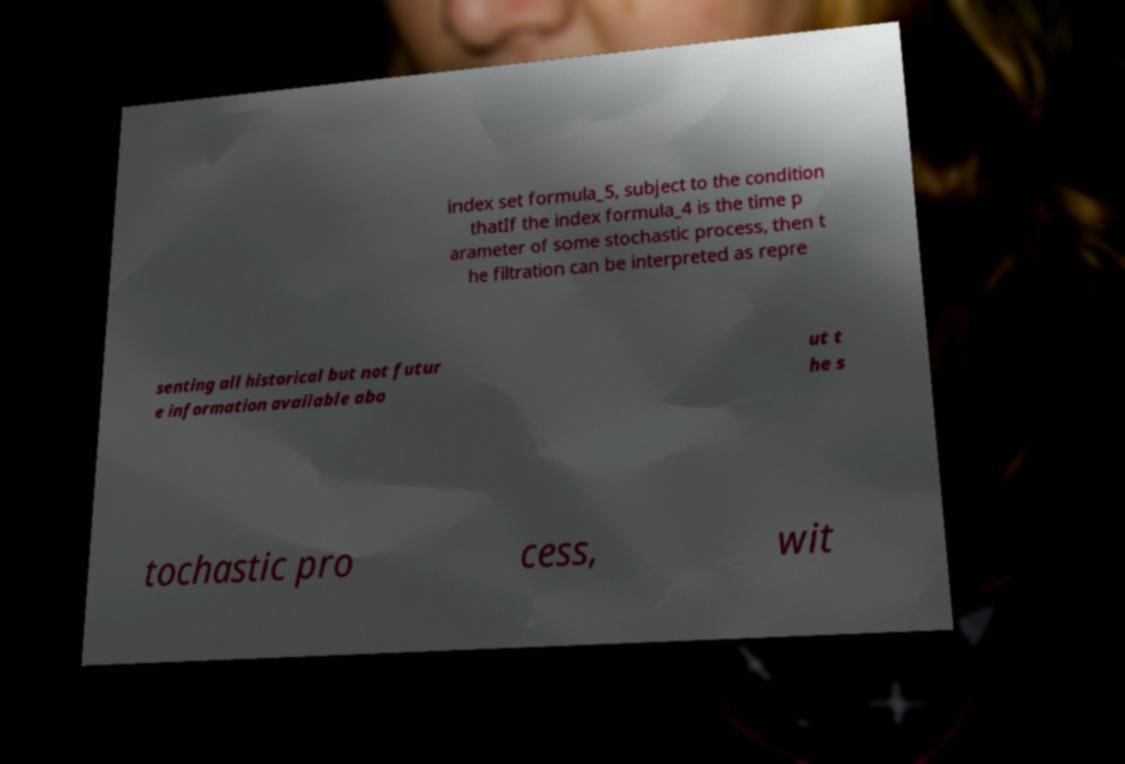Can you read and provide the text displayed in the image?This photo seems to have some interesting text. Can you extract and type it out for me? index set formula_5, subject to the condition thatIf the index formula_4 is the time p arameter of some stochastic process, then t he filtration can be interpreted as repre senting all historical but not futur e information available abo ut t he s tochastic pro cess, wit 